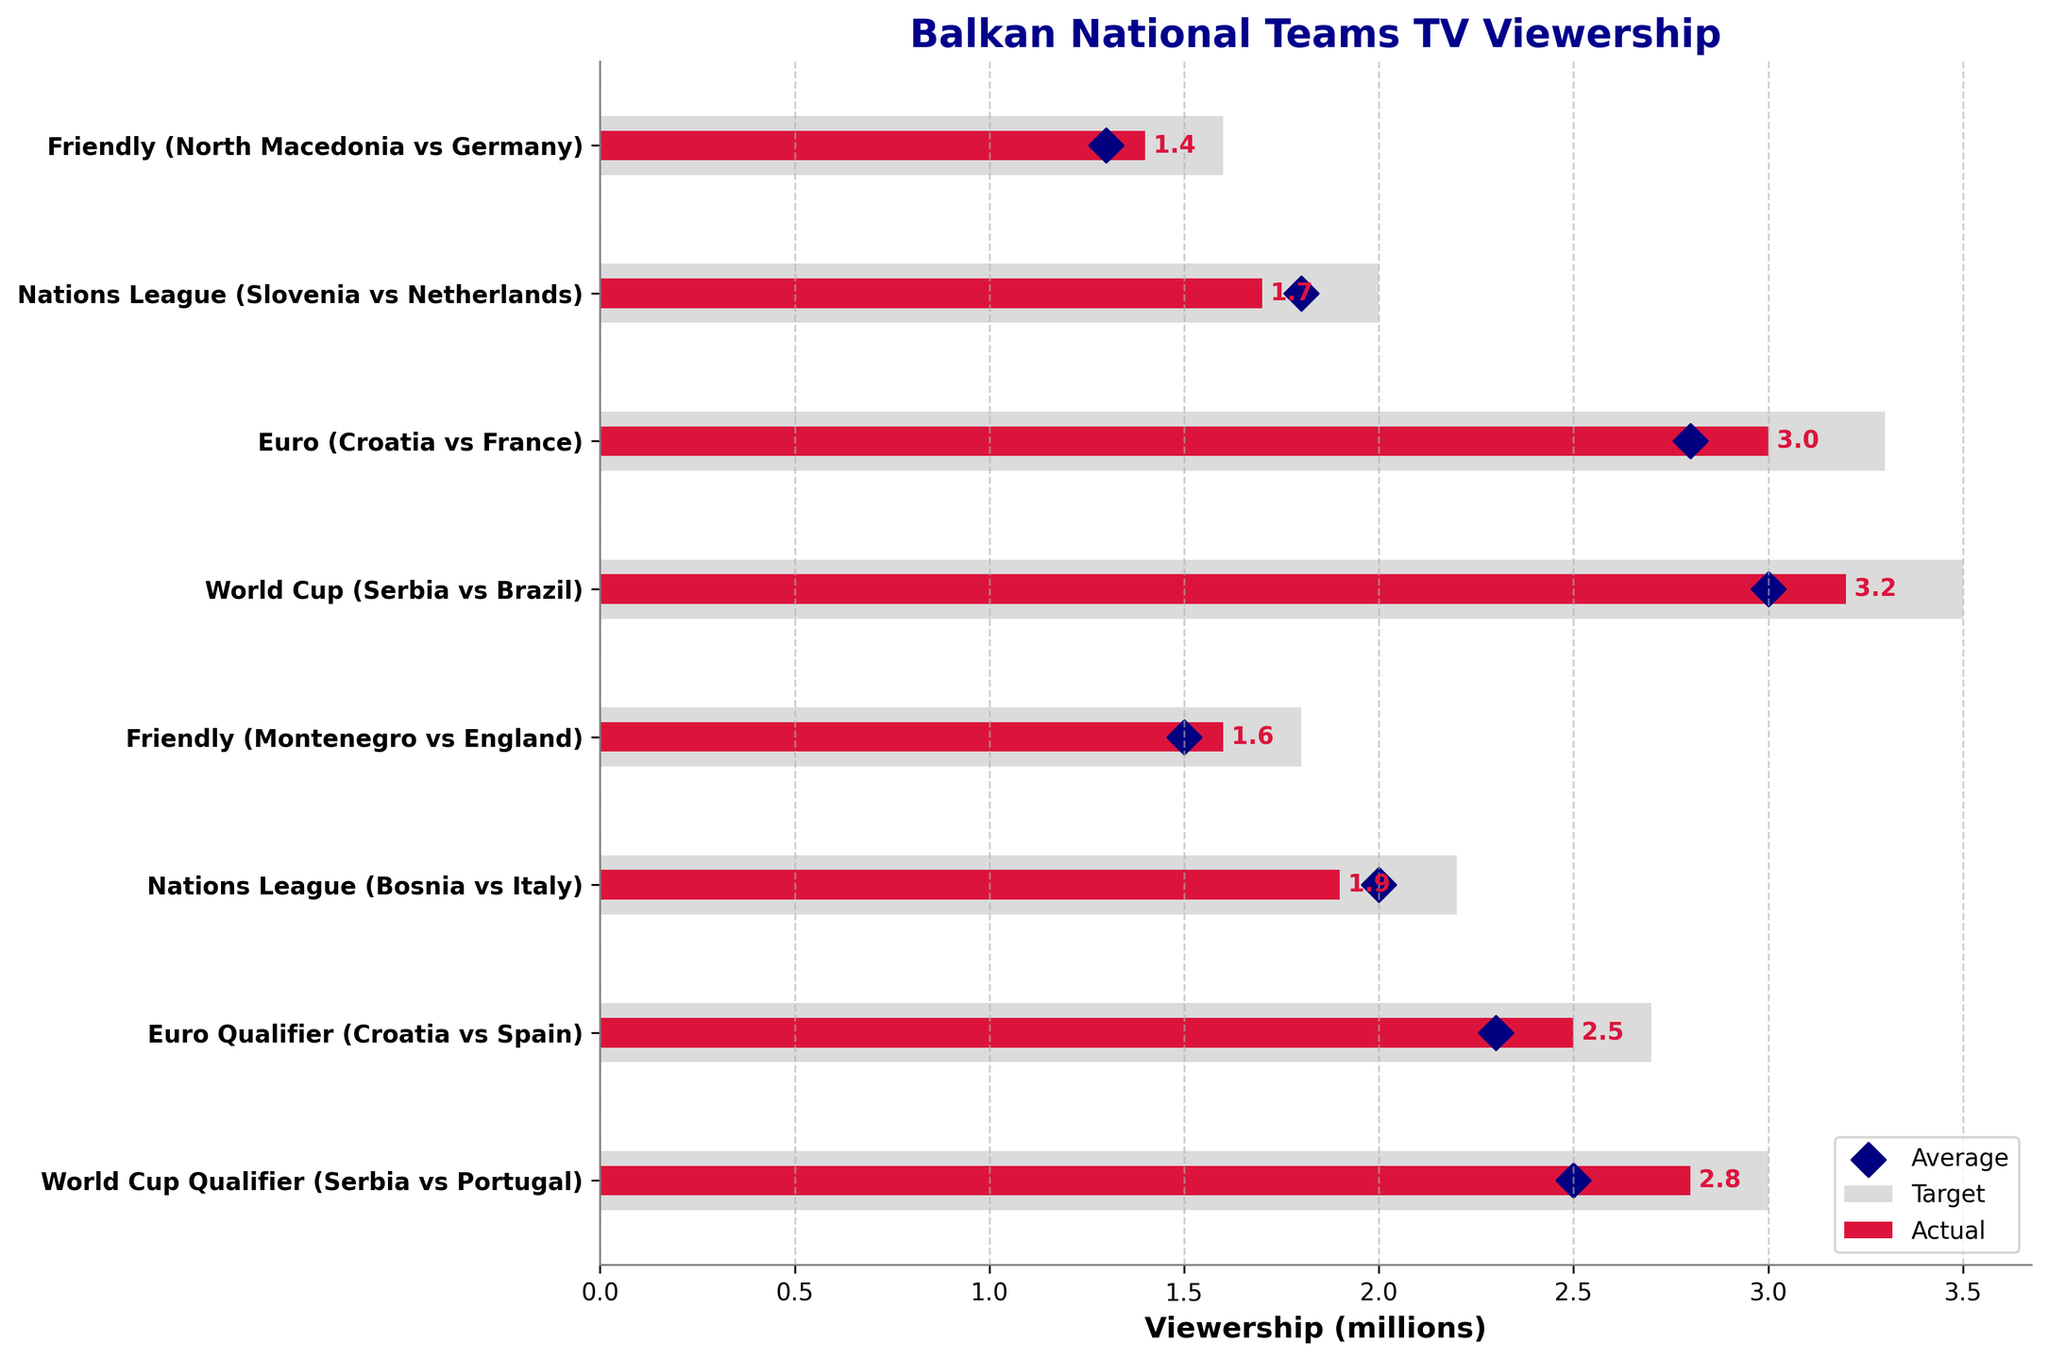What is the title of the figure? The title of a chart is typically located at the top and provides a summary of what the data represents. In this case, it reads "Balkan National Teams TV Viewership".
Answer: Balkan National Teams TV Viewership What are the labels for the x-axis and y-axis? The x-axis and y-axis labels help identify the type of data being represented. The x-axis label here indicates "Viewership (millions)", and the y-axis shows the names of the competitions.
Answer: Viewership (millions) and names of competitions respectively Which competition has the highest actual viewership? To determine this, scan through the actual viewership bars and identify the longest one. The World Cup match between Serbia and Brazil has the longest crimson bar, indicating the highest actual viewership.
Answer: Serbia vs Brazil (World Cup) Which competition has the lowest actual viewership? Observing the shortest bar among the crimson-colored bars reveals that the Friendly match between North Macedonia and Germany recorded the lowest actual viewership.
Answer: North Macedonia vs Germany (Friendly) How many competitions had an actual viewership higher than the average viewership? To answer this, compare the heights of the actual viewership bars with the positions of the corresponding average viewership markers. The competitions with such criteria are Serbia vs Portugal (WC Qualifier), Croatia vs Spain (Euro Qualifier), Serbia vs Brazil (World Cup), Croatia vs France (Euro), and Slovenia vs Netherlands (Nations League), making up a total of five competitions.
Answer: 5 Which competition came the closest to meeting its target viewership? This is determined by finding the smallest difference between the actual and target viewership bars. The competition "Bosnia vs Italy (Nations League)" shows the closest values between its actual (1.9 million) and target viewership (2.2 million).
Answer: Bosnia vs Italy (Nations League) How does the average viewership of the "Euro Qualifier (Croatia vs Spain)" compare to its actual viewership? Looking at the actual viewership bar and the position of the average viewership marker for this competition, the actual viewership (2.5 million) is slightly higher than the average viewership (2.3 million).
Answer: Slightly higher Which competitions had an actual viewership equal to or above their average viewership? By checking the competitions where the actual viewership bars are equal to or exceed the average viewership markers, we find Serbia vs Portugal (WC Qualifier), Croatia vs Spain (Euro Qualifier), Serbia vs Brazil (World Cup), and Croatia vs France (Euro).
Answer: Serbia vs Portugal, Croatia vs Spain, Serbia vs Brazil, Croatia vs France What is the difference in actual viewership between "Serbia vs Portugal (WC Qualifier)" and "Serbia vs Brazil (World Cup)"? Subtracting the actual viewership value for Serbia vs Portugal (2.8 million) from that of Serbia vs Brazil (3.2 million) results in a difference of 0.4 million.
Answer: 0.4 million Compare the actual and target viewership for the "Friendly (Montenegro vs England)" match. Was it above or below the target? By observing the length of the crimson bar (actual) and the light gray bar (target) for this match, it is evident that the actual viewership (1.6 million) is below the target viewership (1.8 million).
Answer: Below the target 